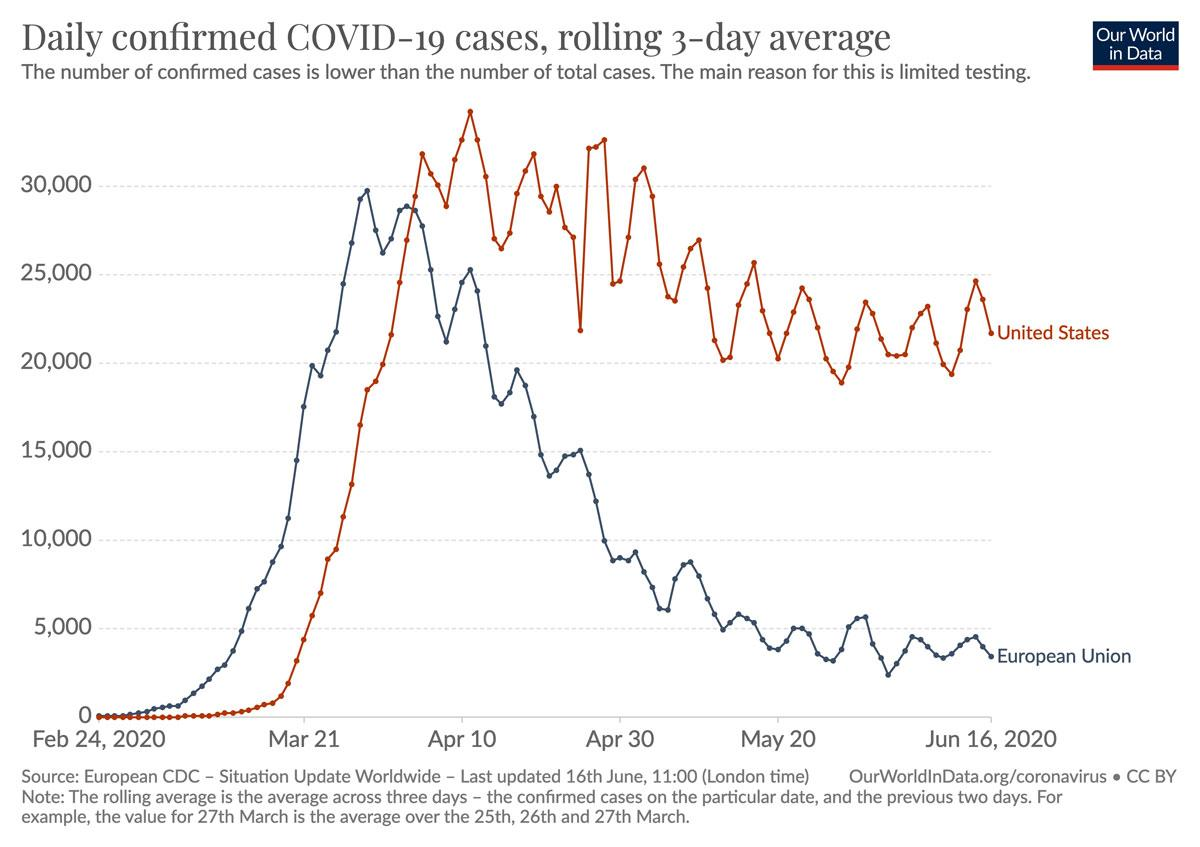Draw attention to some important aspects in this diagram. The total number of confirmed cases is 105,000. The color used to represent the United States is blue. 